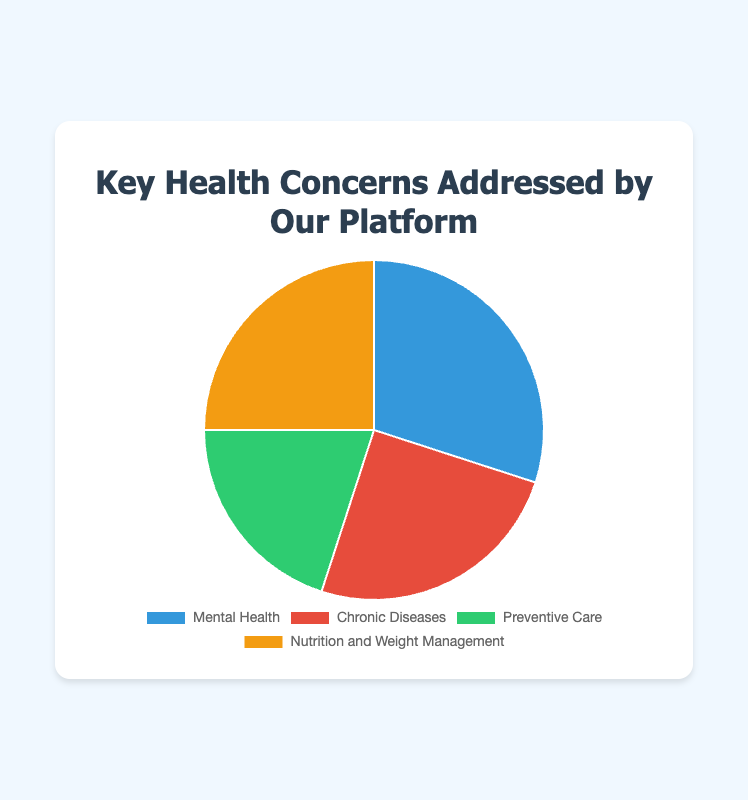What is the percentage of the largest health concern? The largest segment in the pie chart is labeled "Mental Health" and its percentage is shown as 30%.
Answer: 30% Which two health concerns have the same percentage? By examining the pie chart, it is clear that "Chronic Diseases" and "Nutrition and Weight Management" both have percentages of 25%.
Answer: Chronic Diseases and Nutrition and Weight Management How does "Mental Health" compare to "Preventive Care"? "Mental Health" accounts for 30% and "Preventive Care" accounts for 20%. Comparing these values, "Mental Health" is higher by 10 percentage points.
Answer: Mental Health is 10% higher What is the combined percentage of "Chronic Diseases" and "Nutrition and Weight Management"? According to the pie chart, "Chronic Diseases" is 25% and "Nutrition and Weight Management" is 25%. Adding these together gives 25% + 25% = 50%.
Answer: 50% Which health concern is represented by the green section of the pie chart? The green section of the pie chart corresponds to "Preventive Care", which is defined by the color coding in the legend of the chart.
Answer: Preventive Care What is the difference between the lowest and the highest health concern percentages? The highest percentage is for "Mental Health" at 30% and the lowest is "Preventive Care" at 20%. The difference is calculated as 30% - 20% = 10%.
Answer: 10% How do the percentages of "Mental Health" and "Chronic Diseases" together compare to half of the pie chart? "Mental Health" is 30% and "Chronic Diseases" is 25%. Adding them together gives 55%. Half of the pie chart is 50%, hence 55% is 5% more than half of the pie chart.
Answer: 5% higher If "Mental Health" were to increase by 10%, what would its new percentage be? The current percentage of "Mental Health" is 30%. Increasing this by 10% of the total pie (which is 10% of 100% or simply 10%) results in a new percentage of 30% + 10% = 40%.
Answer: 40% What percentage of health concerns is not related to "Preventive Care"? "Preventive Care" accounts for 20%, so subtracting this from the total 100% gives 100% - 20% = 80%.
Answer: 80% 